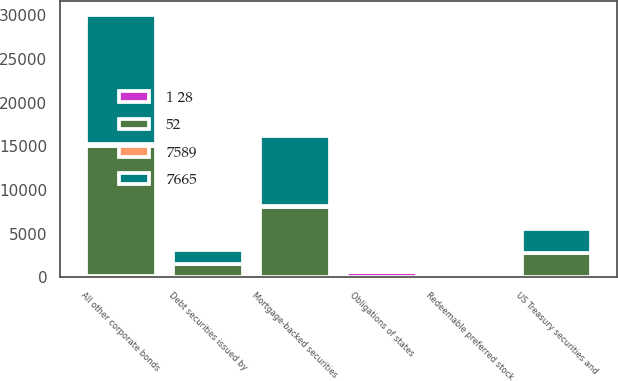<chart> <loc_0><loc_0><loc_500><loc_500><stacked_bar_chart><ecel><fcel>US Treasury securities and<fcel>Obligations of states<fcel>Debt securities issued by<fcel>All other corporate bonds<fcel>Redeemable preferred stock<fcel>Mortgage-backed securities<nl><fcel>52<fcel>2736<fcel>143<fcel>1550<fcel>14866<fcel>101<fcel>7997<nl><fcel>1 28<fcel>13<fcel>661<fcel>12<fcel>165<fcel>16<fcel>66<nl><fcel>7589<fcel>31<fcel>80<fcel>10<fcel>247<fcel>1<fcel>121<nl><fcel>7665<fcel>2718<fcel>143<fcel>1552<fcel>14784<fcel>116<fcel>7942<nl></chart> 